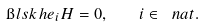<formula> <loc_0><loc_0><loc_500><loc_500>\i l s k { h } { { e } _ { i } } { H } = 0 , \quad i \in \ n a t .</formula> 